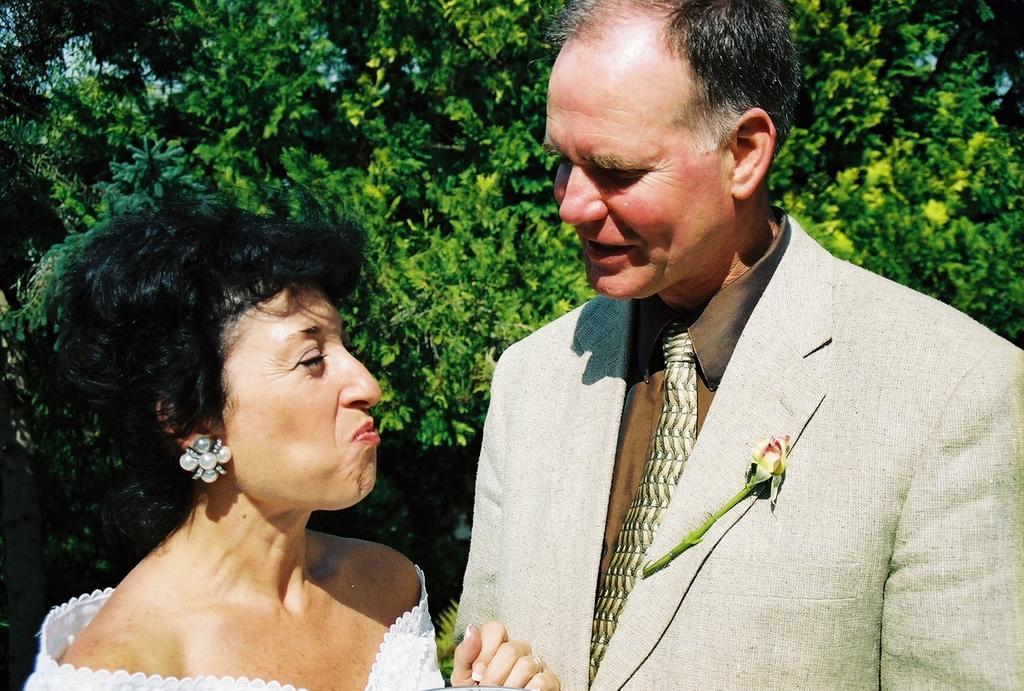Describe this image in one or two sentences. In this picture there is a man and a woman in the center of the image and there is greenery in the background area of the image. 